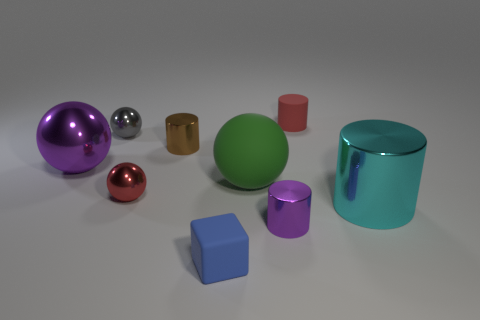Add 1 brown matte things. How many objects exist? 10 Subtract all blocks. How many objects are left? 8 Add 4 big purple spheres. How many big purple spheres exist? 5 Subtract 0 cyan balls. How many objects are left? 9 Subtract all tiny gray matte spheres. Subtract all rubber blocks. How many objects are left? 8 Add 5 green objects. How many green objects are left? 6 